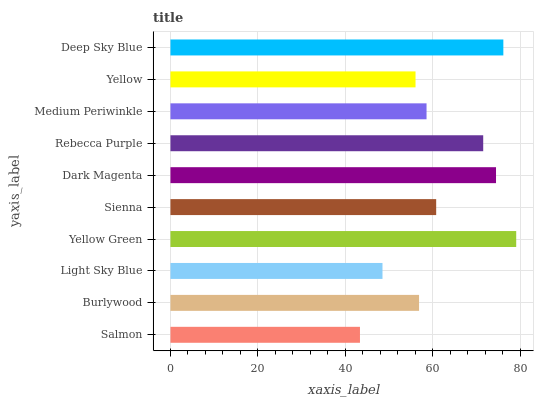Is Salmon the minimum?
Answer yes or no. Yes. Is Yellow Green the maximum?
Answer yes or no. Yes. Is Burlywood the minimum?
Answer yes or no. No. Is Burlywood the maximum?
Answer yes or no. No. Is Burlywood greater than Salmon?
Answer yes or no. Yes. Is Salmon less than Burlywood?
Answer yes or no. Yes. Is Salmon greater than Burlywood?
Answer yes or no. No. Is Burlywood less than Salmon?
Answer yes or no. No. Is Sienna the high median?
Answer yes or no. Yes. Is Medium Periwinkle the low median?
Answer yes or no. Yes. Is Salmon the high median?
Answer yes or no. No. Is Rebecca Purple the low median?
Answer yes or no. No. 